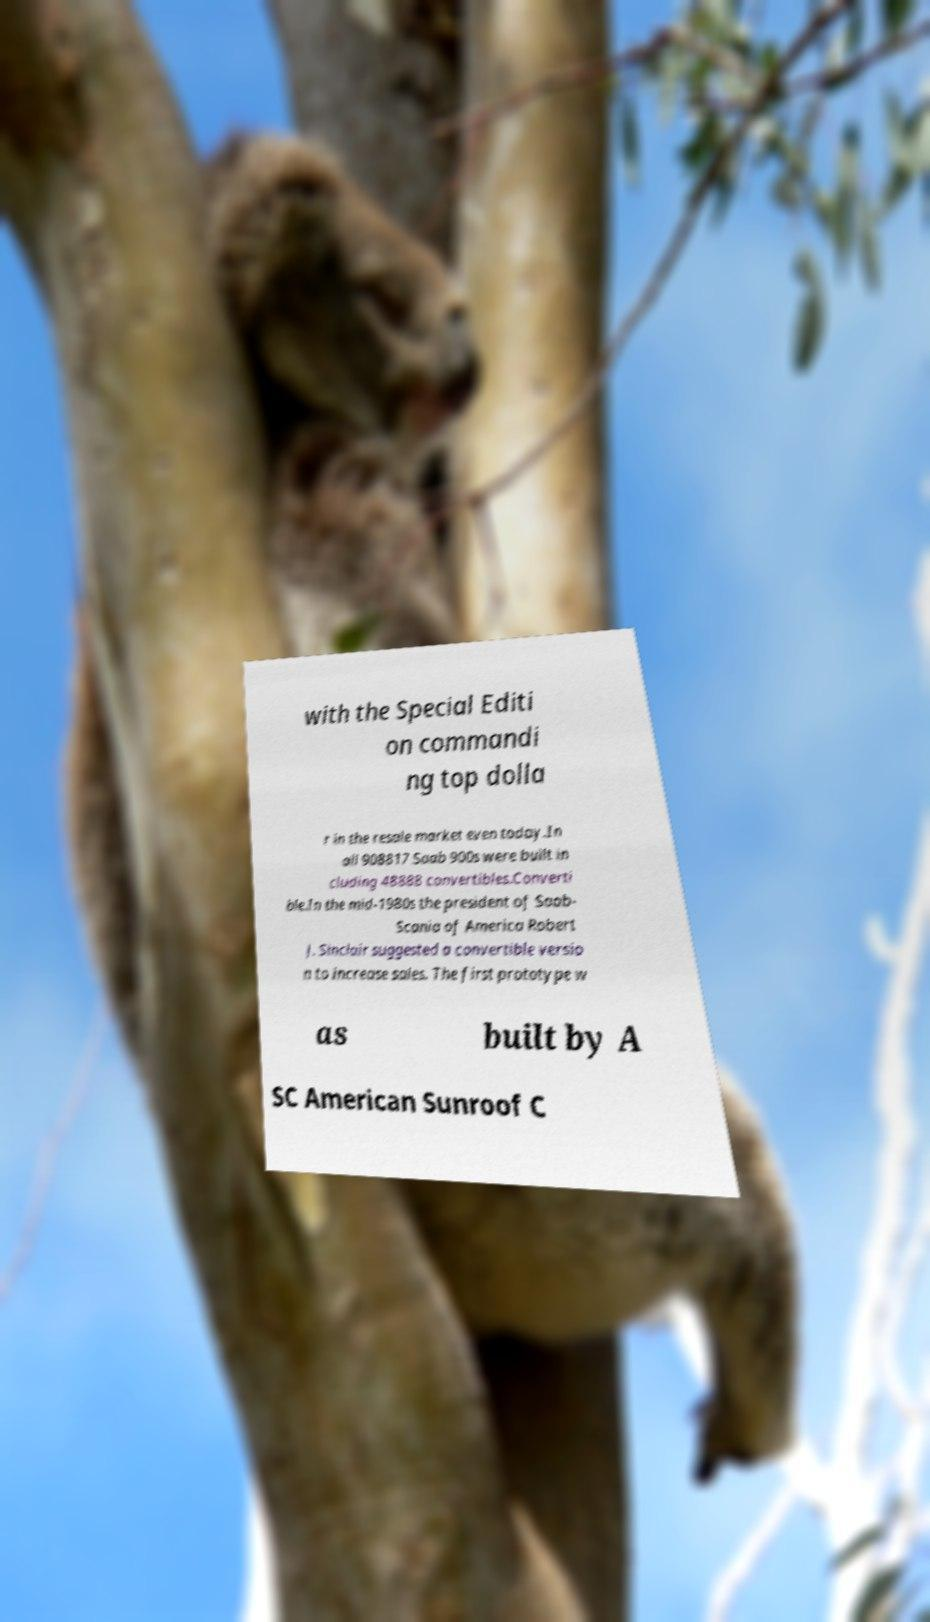For documentation purposes, I need the text within this image transcribed. Could you provide that? with the Special Editi on commandi ng top dolla r in the resale market even today.In all 908817 Saab 900s were built in cluding 48888 convertibles.Converti ble.In the mid-1980s the president of Saab- Scania of America Robert J. Sinclair suggested a convertible versio n to increase sales. The first prototype w as built by A SC American Sunroof C 